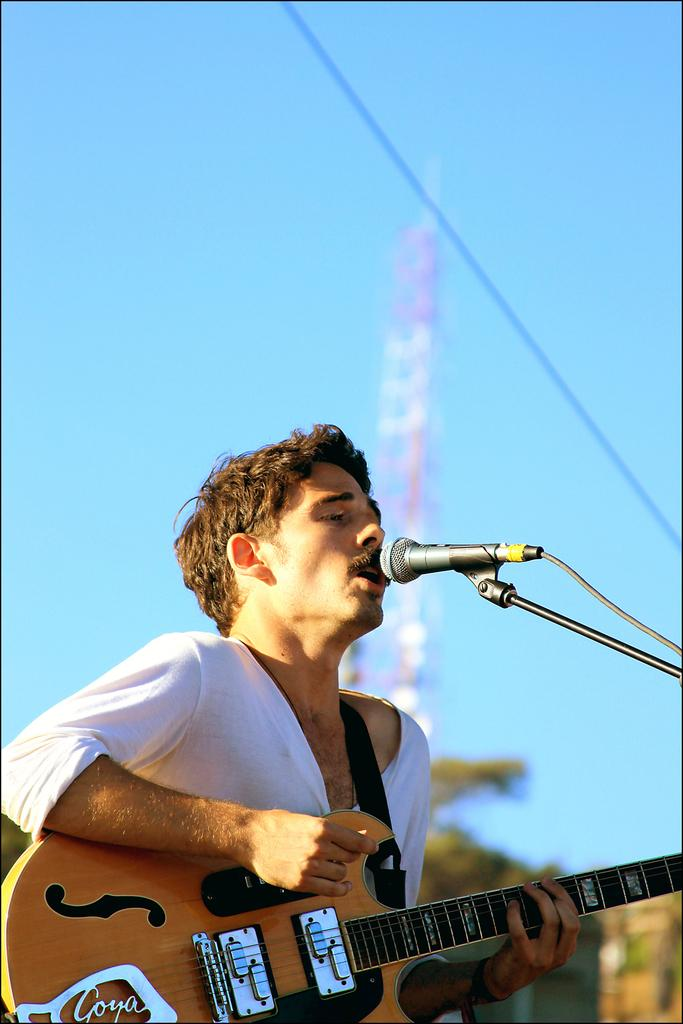What is the main subject of the image? There is a person in the center of the image. What is the person doing in the image? The person is playing a guitar and singing on a microphone. What can be seen in the background of the image? There is a sky visible in the background of the image. What type of knee injury is the person experiencing in the image? There is no indication of a knee injury in the image; the person is playing a guitar and singing on a microphone. What type of police equipment can be seen in the image? There is no police equipment present in the image. 